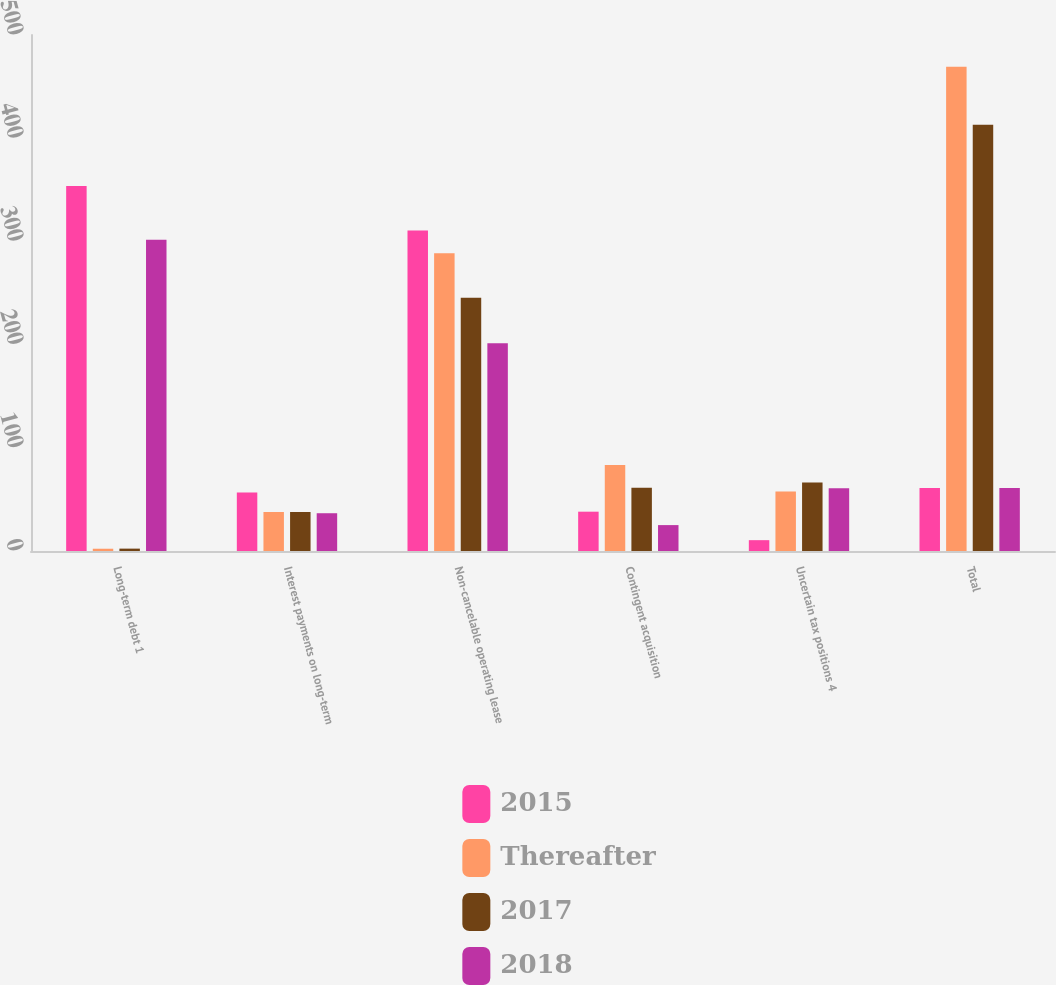<chart> <loc_0><loc_0><loc_500><loc_500><stacked_bar_chart><ecel><fcel>Long-term debt 1<fcel>Interest payments on long-term<fcel>Non-cancelable operating lease<fcel>Contingent acquisition<fcel>Uncertain tax positions 4<fcel>Total<nl><fcel>2015<fcel>353.6<fcel>56.8<fcel>310.6<fcel>38.1<fcel>10.5<fcel>61<nl><fcel>Thereafter<fcel>2.2<fcel>37.8<fcel>288.4<fcel>83.3<fcel>57.6<fcel>469.3<nl><fcel>2017<fcel>2.3<fcel>37.8<fcel>245.3<fcel>61.3<fcel>66.4<fcel>413.1<nl><fcel>2018<fcel>301.7<fcel>36.6<fcel>201.3<fcel>25.1<fcel>60.7<fcel>61<nl></chart> 